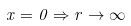<formula> <loc_0><loc_0><loc_500><loc_500>x = 0 \Rightarrow r \rightarrow \infty</formula> 